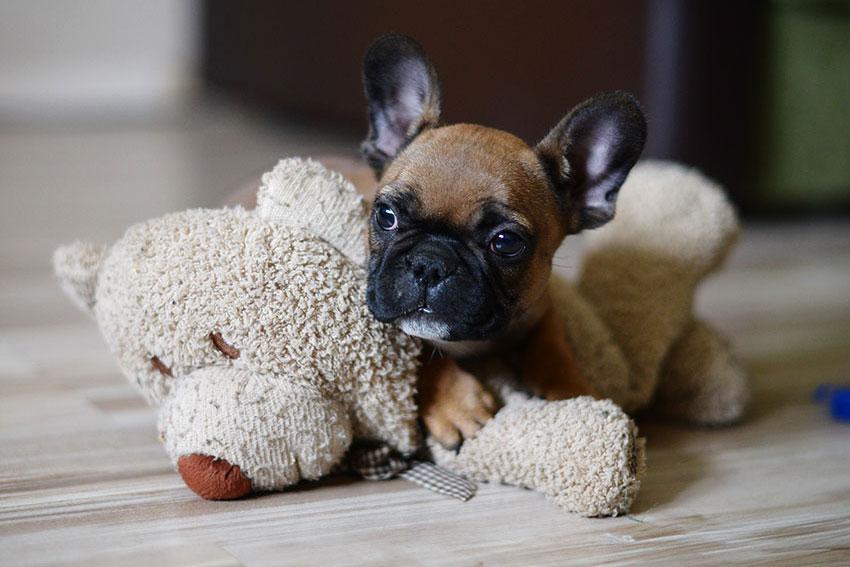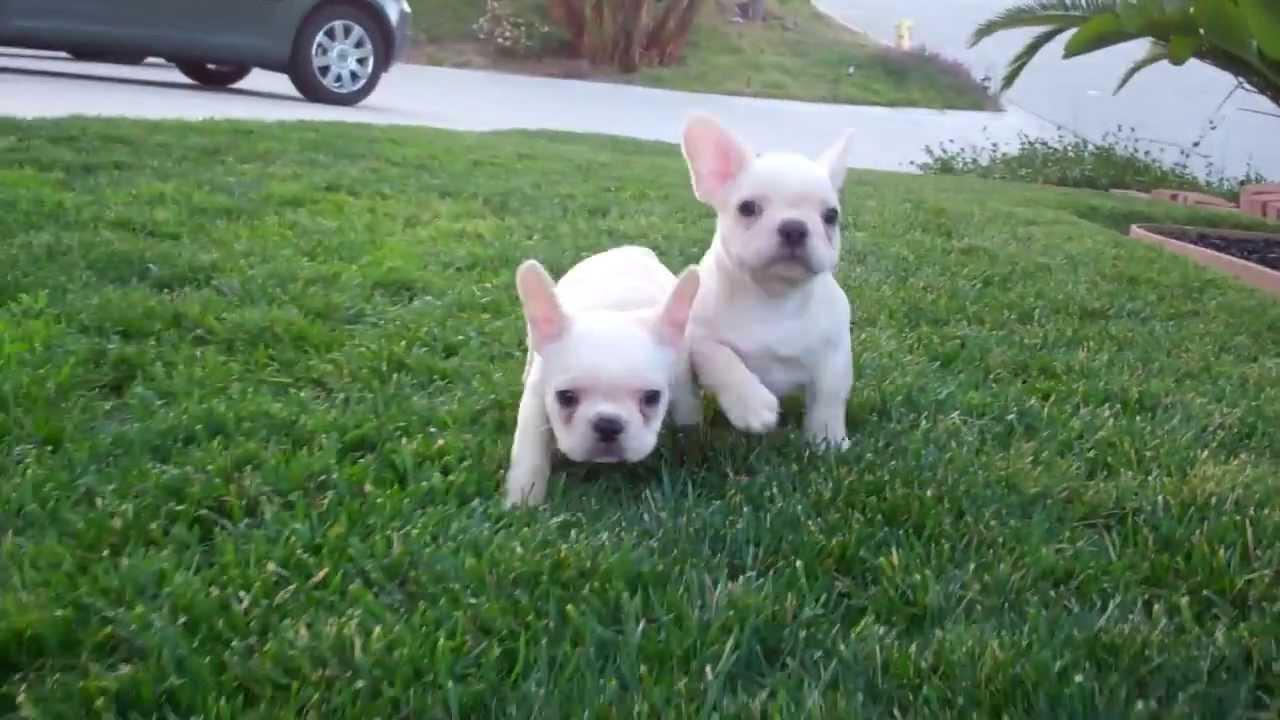The first image is the image on the left, the second image is the image on the right. Given the left and right images, does the statement "One image shows a tan big-eared dog standing with its body turned forward and holding a solid-colored toy in its mouth." hold true? Answer yes or no. No. The first image is the image on the left, the second image is the image on the right. For the images displayed, is the sentence "The right image contains at least two dogs." factually correct? Answer yes or no. Yes. 